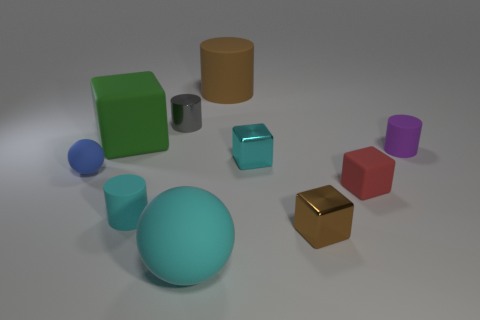Are there any other things of the same color as the big cylinder?
Keep it short and to the point. Yes. There is a cyan rubber sphere; is it the same size as the matte cylinder right of the tiny brown cube?
Provide a short and direct response. No. The green cube is what size?
Your response must be concise. Large. Is the shape of the blue object the same as the large cyan object?
Your answer should be very brief. Yes. There is a rubber ball that is behind the big object in front of the tiny shiny thing that is in front of the small cyan metal object; what color is it?
Provide a short and direct response. Blue. Are the tiny cyan object that is in front of the small blue matte ball and the large thing in front of the tiny brown cube made of the same material?
Provide a short and direct response. Yes. There is a cyan thing that is left of the gray shiny cylinder; what shape is it?
Your answer should be very brief. Cylinder. How many things are large green matte cubes or balls in front of the blue matte thing?
Your answer should be very brief. 2. Is the material of the green cube the same as the gray cylinder?
Make the answer very short. No. Are there an equal number of big brown things on the right side of the big brown cylinder and balls that are behind the tiny purple matte cylinder?
Offer a very short reply. Yes. 